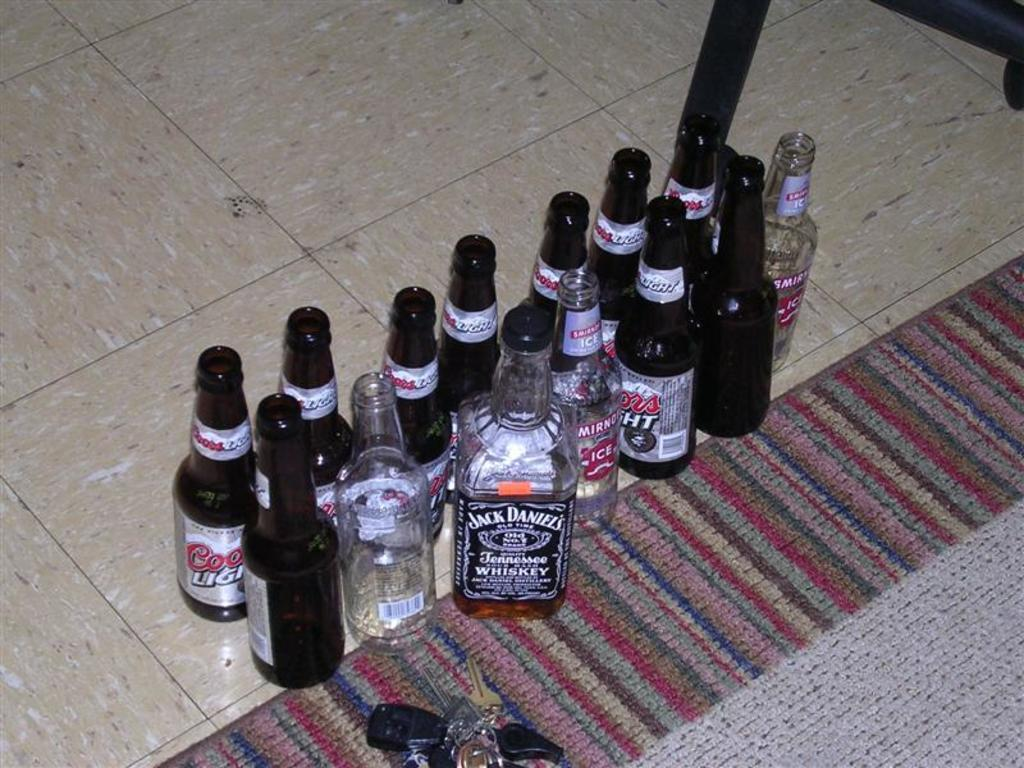<image>
Write a terse but informative summary of the picture. two rows of empty coors and jack daniels bottles on the floor 